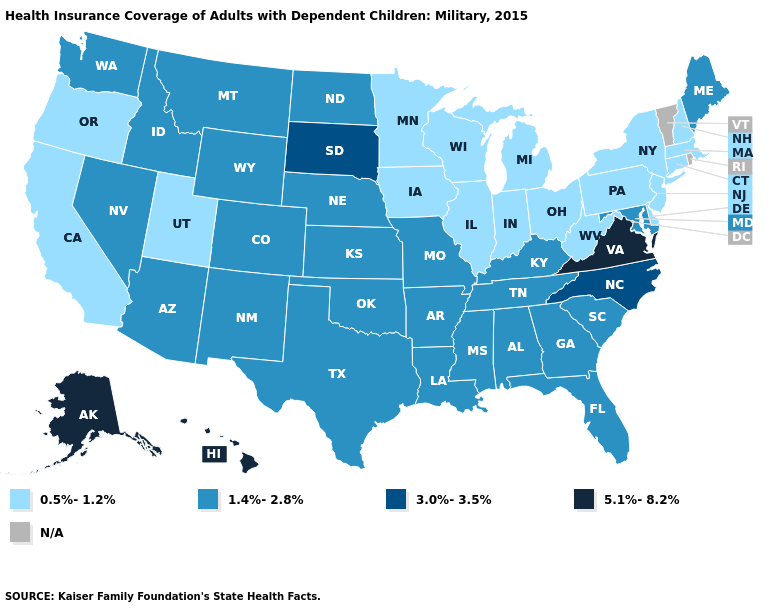Name the states that have a value in the range 0.5%-1.2%?
Quick response, please. California, Connecticut, Delaware, Illinois, Indiana, Iowa, Massachusetts, Michigan, Minnesota, New Hampshire, New Jersey, New York, Ohio, Oregon, Pennsylvania, Utah, West Virginia, Wisconsin. What is the lowest value in the Northeast?
Concise answer only. 0.5%-1.2%. Among the states that border Colorado , does Arizona have the highest value?
Concise answer only. Yes. Name the states that have a value in the range 5.1%-8.2%?
Concise answer only. Alaska, Hawaii, Virginia. Among the states that border Georgia , does North Carolina have the lowest value?
Write a very short answer. No. What is the value of Vermont?
Quick response, please. N/A. What is the value of Georgia?
Quick response, please. 1.4%-2.8%. What is the highest value in states that border Maine?
Be succinct. 0.5%-1.2%. Which states have the highest value in the USA?
Short answer required. Alaska, Hawaii, Virginia. Does the map have missing data?
Be succinct. Yes. What is the value of Missouri?
Quick response, please. 1.4%-2.8%. Among the states that border Florida , which have the lowest value?
Answer briefly. Alabama, Georgia. Name the states that have a value in the range 3.0%-3.5%?
Answer briefly. North Carolina, South Dakota. Name the states that have a value in the range N/A?
Be succinct. Rhode Island, Vermont. Does Hawaii have the highest value in the West?
Quick response, please. Yes. 